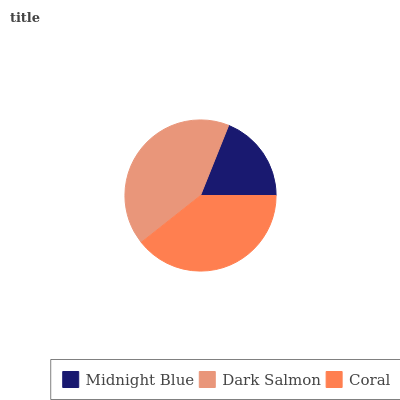Is Midnight Blue the minimum?
Answer yes or no. Yes. Is Dark Salmon the maximum?
Answer yes or no. Yes. Is Coral the minimum?
Answer yes or no. No. Is Coral the maximum?
Answer yes or no. No. Is Dark Salmon greater than Coral?
Answer yes or no. Yes. Is Coral less than Dark Salmon?
Answer yes or no. Yes. Is Coral greater than Dark Salmon?
Answer yes or no. No. Is Dark Salmon less than Coral?
Answer yes or no. No. Is Coral the high median?
Answer yes or no. Yes. Is Coral the low median?
Answer yes or no. Yes. Is Midnight Blue the high median?
Answer yes or no. No. Is Midnight Blue the low median?
Answer yes or no. No. 